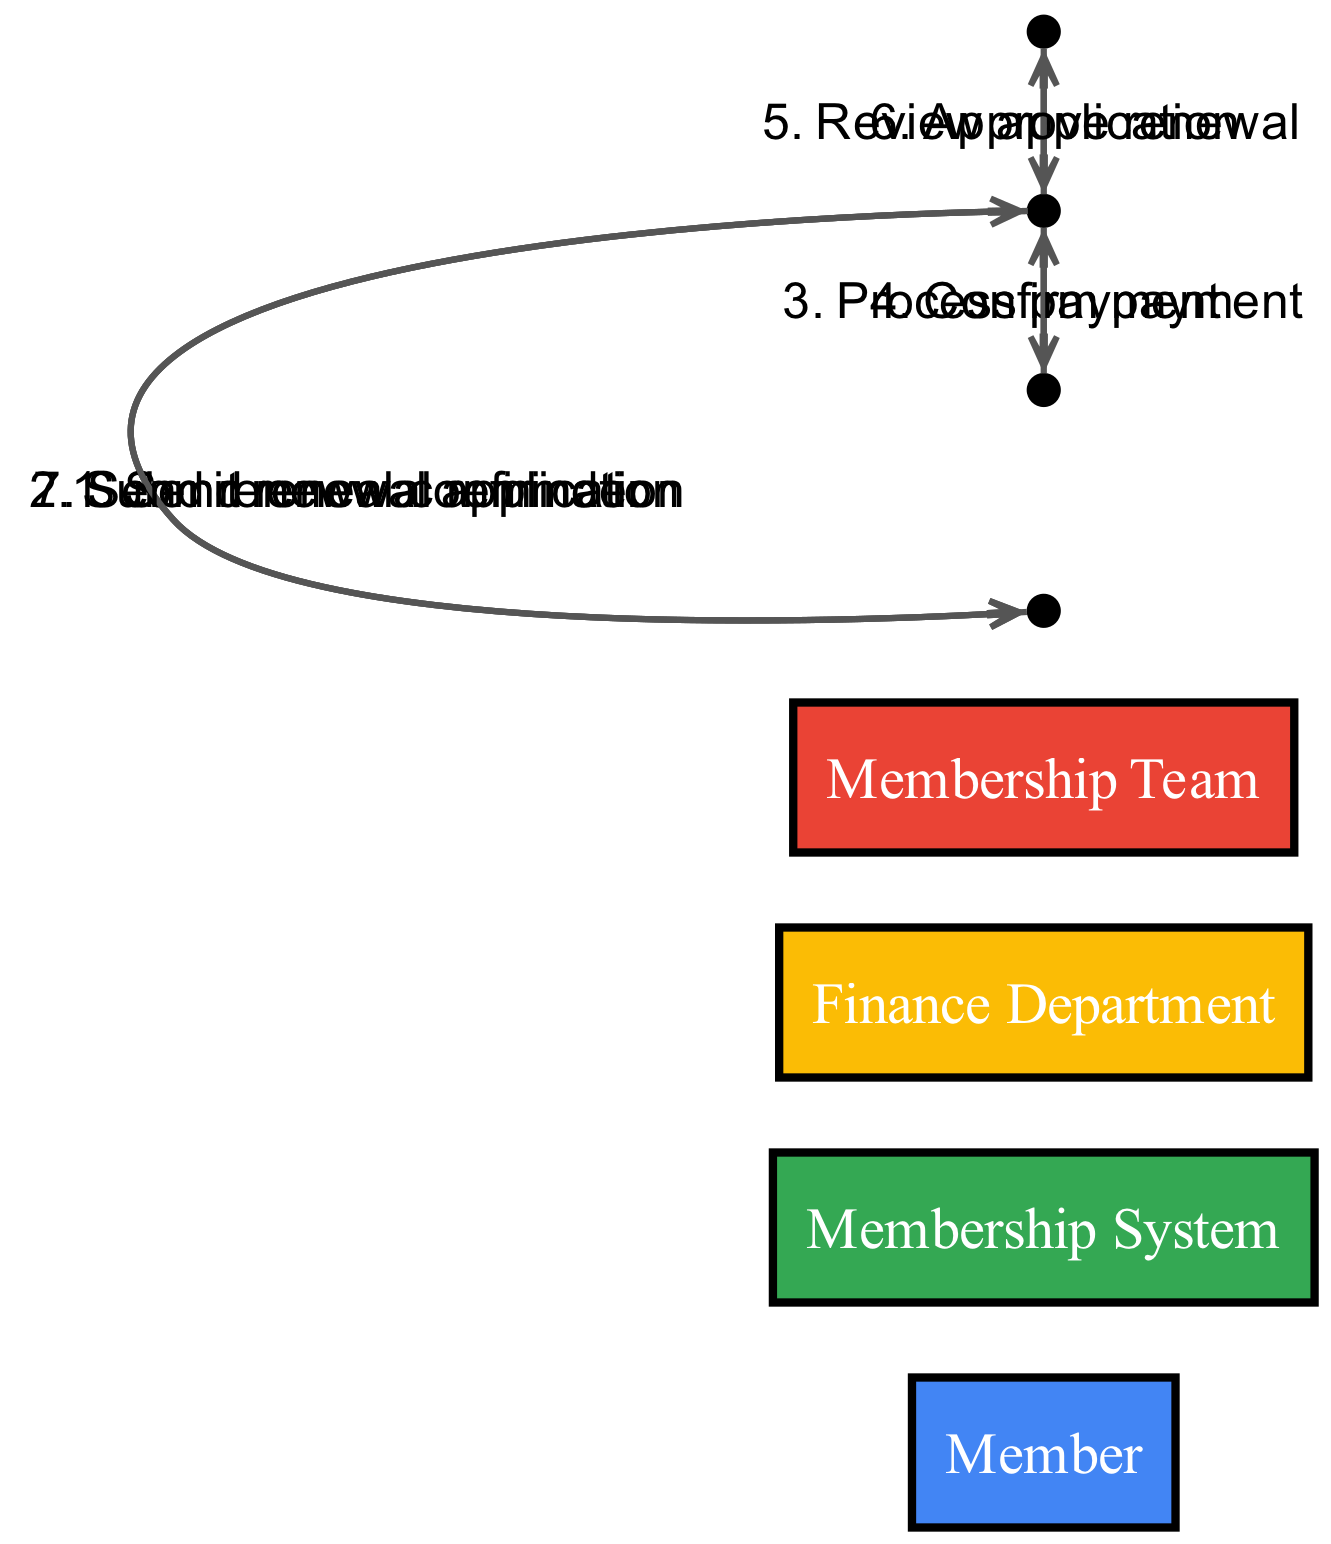What is the first action taken in the workflow? The first action depicted in the diagram is the "Send renewal reminder" message from the Membership System to the Member. This message initiates the entire renewal process.
Answer: Send renewal reminder How many actors are involved in this workflow? The diagram illustrates four distinct actors: Member, Membership System, Finance Department, and Membership Team. Counting these actors gives us the total.
Answer: Four What message does the Finance Department send back to the Membership System? The Finance Department sends "Confirm payment" back to the Membership System. This indicates that the payment processing step has been completed successfully.
Answer: Confirm payment Which actor approves the membership renewal? The Membership Team is responsible for approving the renewal, as indicated by the message "Approve renewal" sent from Membership Team to Membership System.
Answer: Membership Team What happens right after the Member submits the renewal application? After the Member submits the renewal application, the next action is that the Membership System processes the payment by sending the message "Process payment" to the Finance Department.
Answer: Process payment How many messages are exchanged in total during the workflow? The total number of messages exchanged in this workflow includes six messages as detailed in the sequence, starting from the renewal reminder to the confirmation.
Answer: Six What is the last action in the workflow? The last action is "Send renewal confirmation," which is a message sent from the Membership System back to the Member, indicating completion of the renewal process.
Answer: Send renewal confirmation Which actor initiates the payment processing step? The actor initiating the payment processing step is the Membership System, which sends the message "Process payment" to the Finance Department.
Answer: Membership System 